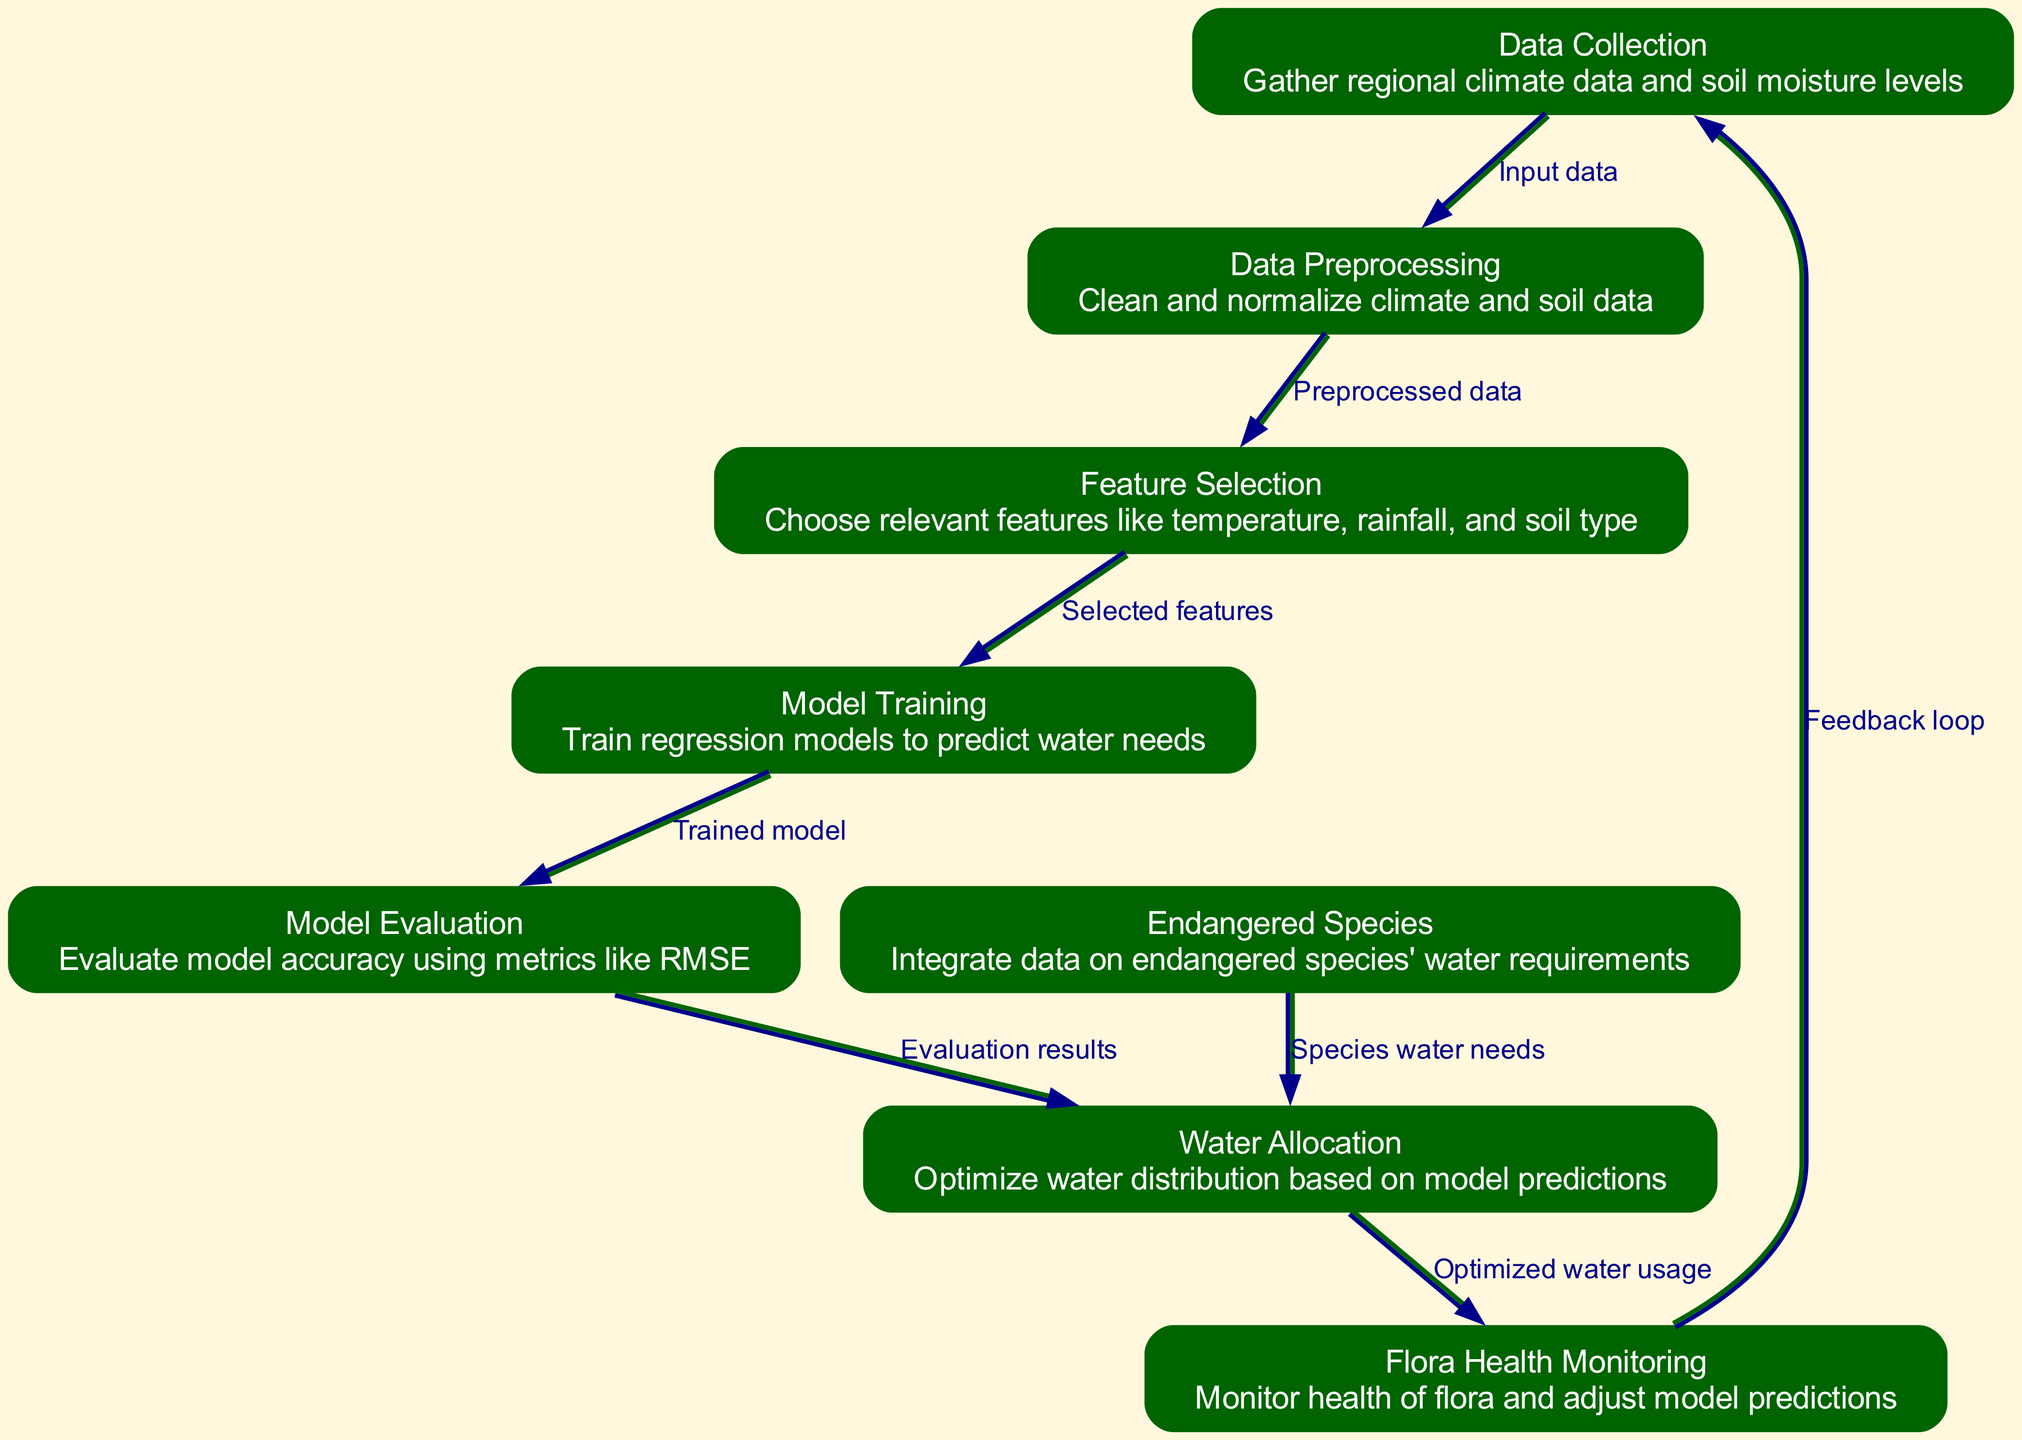What is the first node in the diagram? The first node in the diagram is "Data Collection" as indicated at the top of the flow, which gathers regional climate data and soil moisture levels.
Answer: Data Collection How many nodes are present in the diagram? Counting the nodes listed in the diagram, there are eight distinct nodes, each representing a step in the process.
Answer: 8 What is the relationship between "Model Evaluation" and "Water Allocation"? The relationship is that the output of "Model Evaluation," which consists of evaluation results, is directed as input to "Water Allocation," indicating a sequential relationship in the process.
Answer: Evaluation results Which node monitors the health of flora? The node labeled "Flora Health Monitoring" is responsible for monitoring the health of flora as shown in the diagram.
Answer: Flora Health Monitoring What input does "Feature Selection" require? "Feature Selection" requires input from "Data Preprocessing," which provides the preprocessed data needed for selecting relevant features.
Answer: Preprocessed data Which two nodes are directly connected to "Water Allocation"? "Water Allocation" is directly connected from "Model Evaluation," receiving evaluation results, and from "Endangered Species," which integrates species water needs.
Answer: Model Evaluation and Endangered Species How does "Flora Health Monitoring" affect the data collection process? "Flora Health Monitoring" provides feedback that influences the "Data Collection" node, creating a feedback loop that adjusts future data gathering based on health monitoring outcomes.
Answer: Feedback loop What type of data is integrated in the "Endangered Species" node? The "Endangered Species" node integrates data on endangered species and their specific water requirements, which is vital for optimizing water allocation.
Answer: Species water needs 